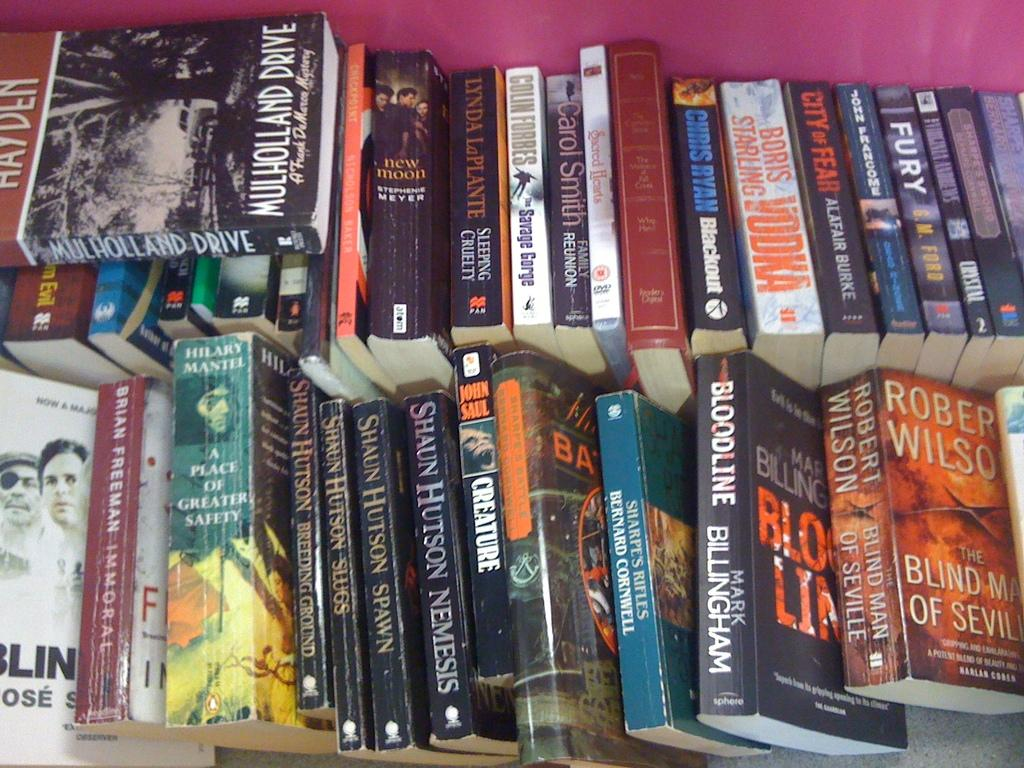<image>
Summarize the visual content of the image. Two rows of books are stacked on each other side by side with a copy of mullholland drive sitting at the top of the first row. 